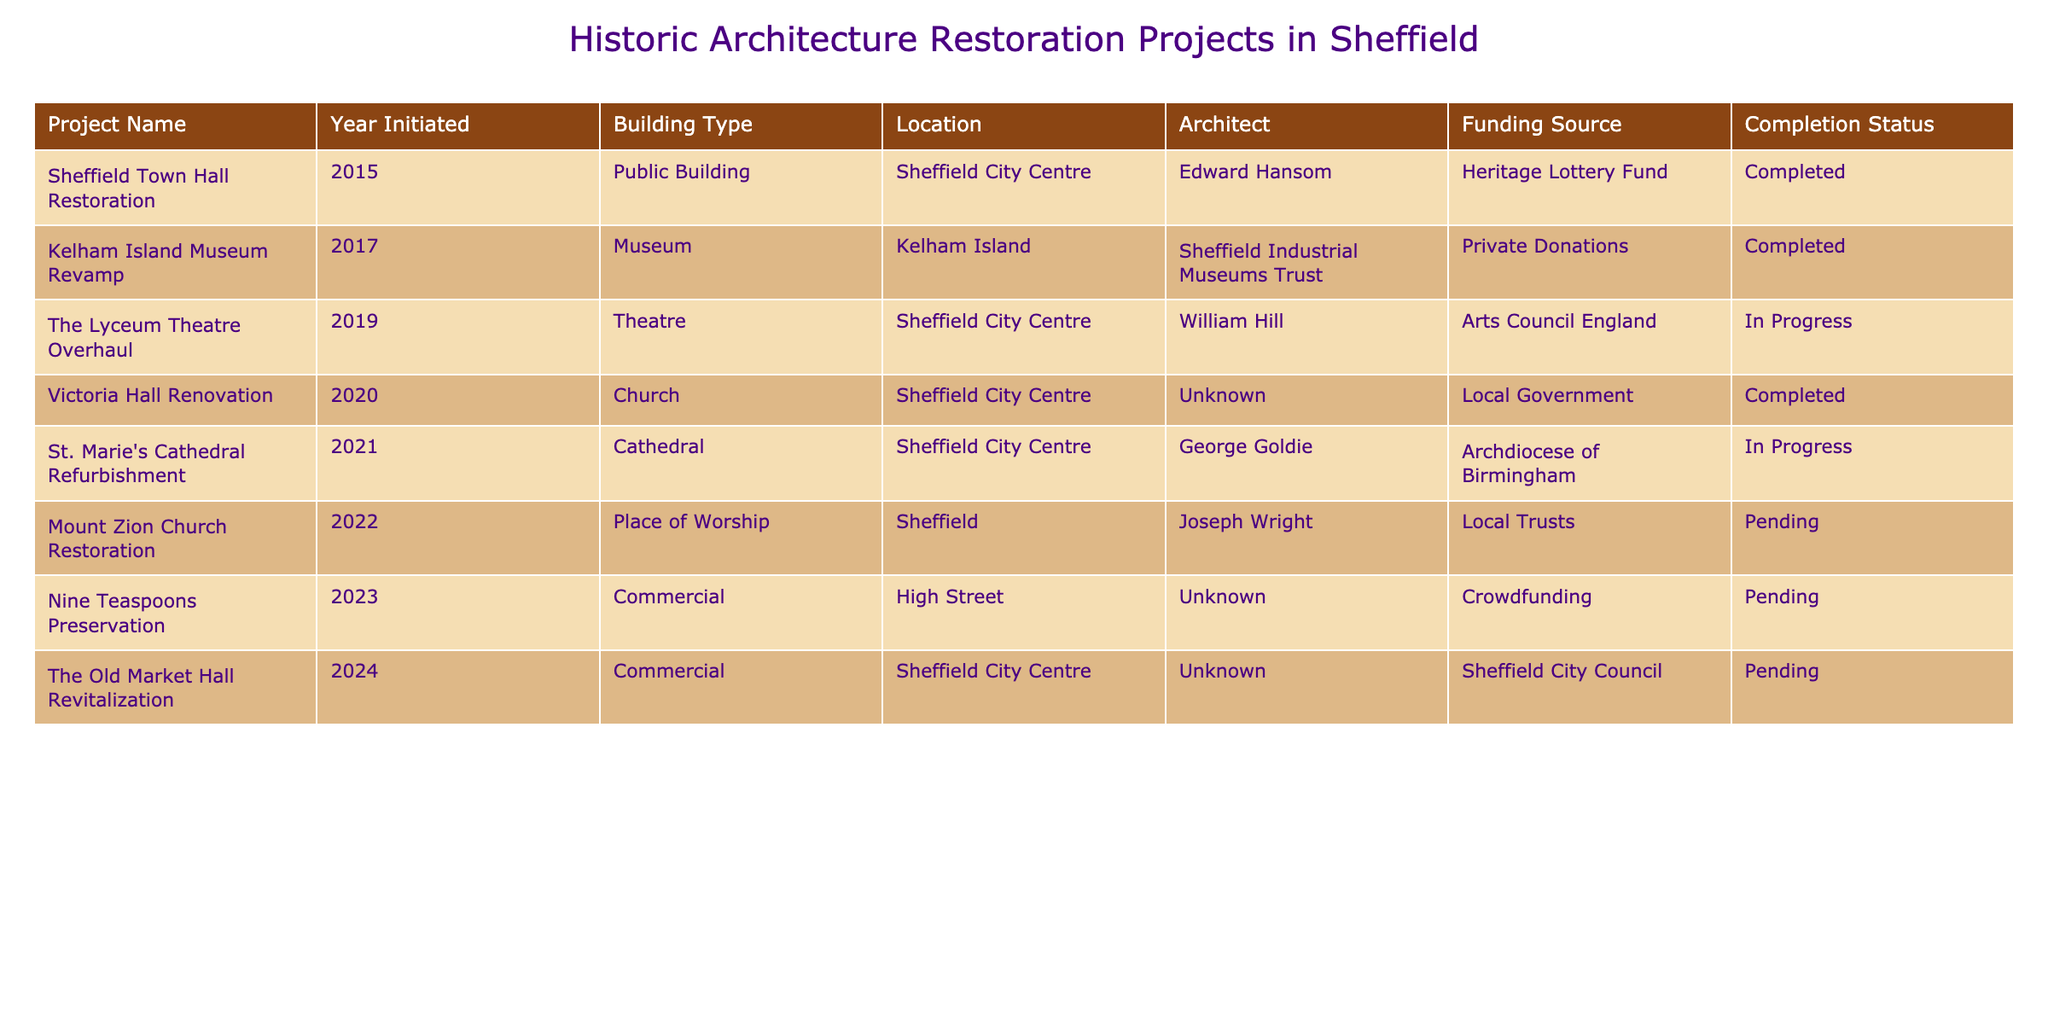What is the total number of restoration projects listed? The table lists 8 restoration projects under the column "Project Name." By counting each unique entry, we arrive at the total of 8 projects.
Answer: 8 Which project was initiated in the year 2021? In the year 2021, the project listed is "St. Marie's Cathedral Refurbishment." We find this by scanning the "Year Initiated" column for the year 2021.
Answer: St. Marie's Cathedral Refurbishment What is the completion status of the "Victoria Hall Renovation"? The "Completion Status" column shows that the "Victoria Hall Renovation" is marked as "Completed." We look at the specific row for that project to find its status.
Answer: Completed Which architect is associated with the Sheffield Town Hall Restoration? The "Architect" column indicates that the architect for the "Sheffield Town Hall Restoration" is Edward Hansom. We find this by locating the row for that specific project.
Answer: Edward Hansom How many restoration projects are currently in progress? There are 2 projects marked as "In Progress," namely "The Lyceum Theatre Overhaul" and "St. Marie's Cathedral Refurbishment." We count the entries in the "Completion Status" column that say "In Progress."
Answer: 2 Is the "Mount Zion Church Restoration" fully funded? The table shows the "Mount Zion Church Restoration" project as "Pending," which suggests that it is not fully funded yet. We determine this by looking at the "Completion Status" for that project.
Answer: No Which funding source is most common among the projects? By reviewing the "Funding Source" column, "Local Government" appears once, "Heritage Lottery Fund" once, "Private Donations" once, "Archdiocese of Birmingham" once, "Local Trusts" once, and "Crowdfunding" once; however, "Sheffield City Council" appears once as well. All have only one occurrence, so they are equally common in this table.
Answer: All sources are equally common; each appears once What is the building type of the "Nine Teaspoons Preservation" project? Checking the "Building Type" column, we see that the project "Nine Teaspoons Preservation" is categorized as "Commercial." We locate this information by finding the related row.
Answer: Commercial Which project was initiated in a church building type and what is its completion status? The project "Victoria Hall Renovation" is in a church building type and has a completion status of "Completed." We identify this by looking at the "Building Type" and its completion status in the relevant row.
Answer: Victoria Hall Renovation, Completed What is the difference in the statuses of the "Mount Zion Church Restoration" and "Kelham Island Museum Revamp" projects? "Mount Zion Church Restoration" is marked as "Pending," while "Kelham Island Museum Revamp" is marked as "Completed." The difference is that one is still pending completion and the other has been completed.
Answer: Pending vs. Completed 